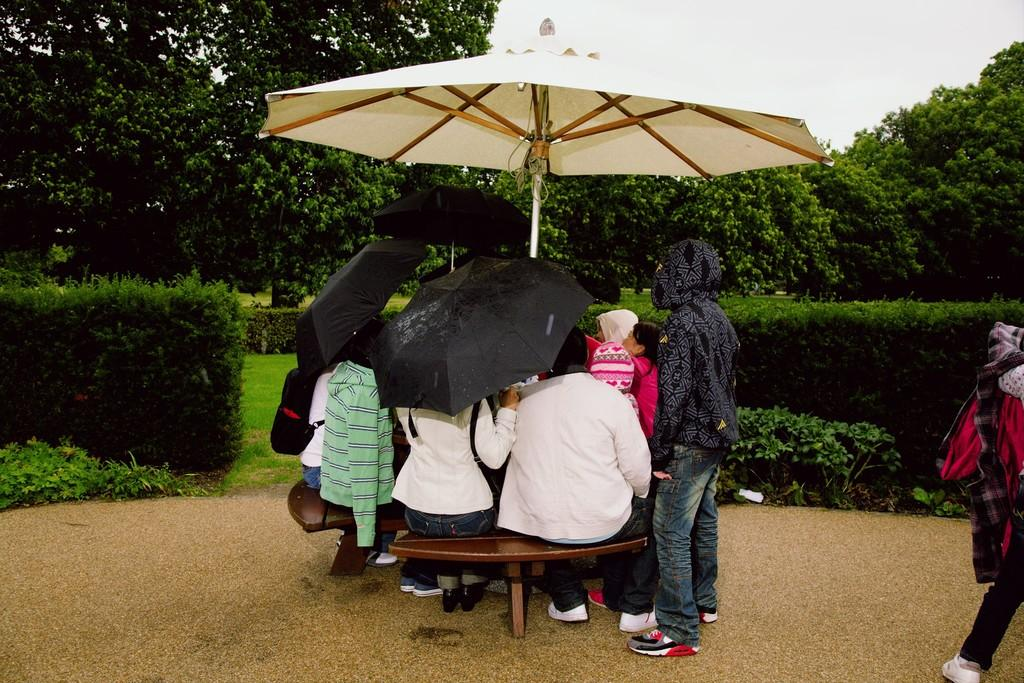What are the people doing in the image? The people are sitting under an umbrella. Where are the people sitting? The people are sitting on a bench. What can be seen in the background of the image? There are trees in the image. How many babies are sitting on the sofa in the image? There is no sofa or babies present in the image. What color is the orange that the people are holding in the image? There is no orange present in the image. 